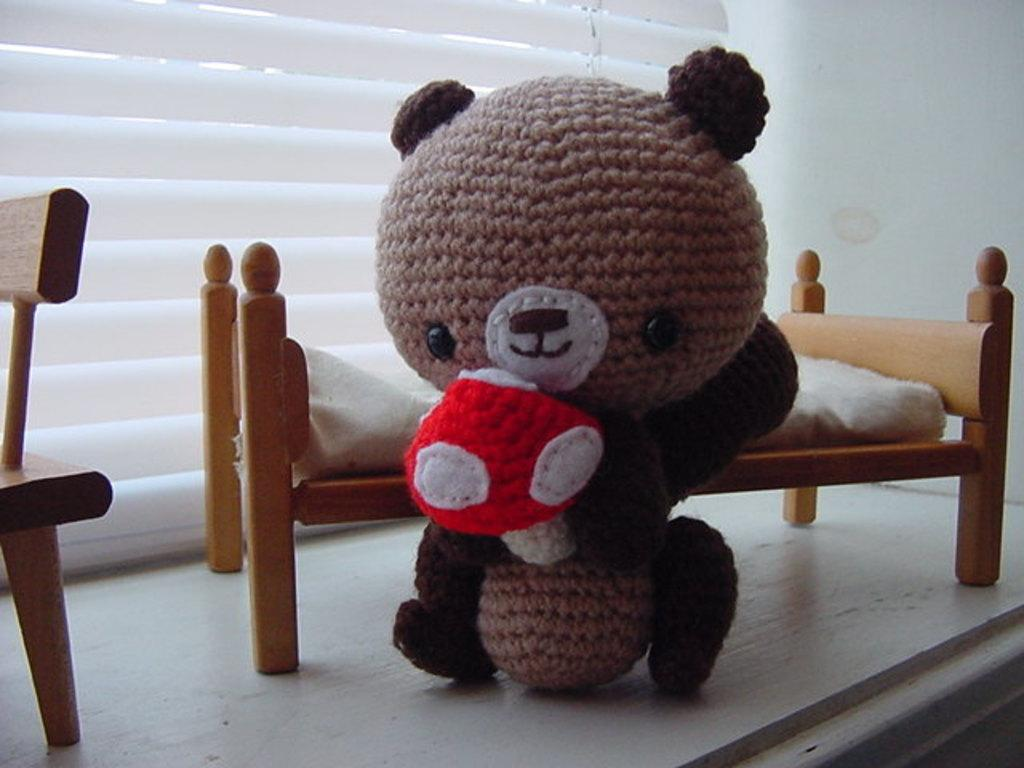What is the main subject in the center of the image? There is a soft toy in the center of the image. What can be seen in the background of the image? There is a toy cot, a chair, blinds, and a wall in the background of the image. What is the price of the plantation shown in the image? There is no plantation present in the image. 